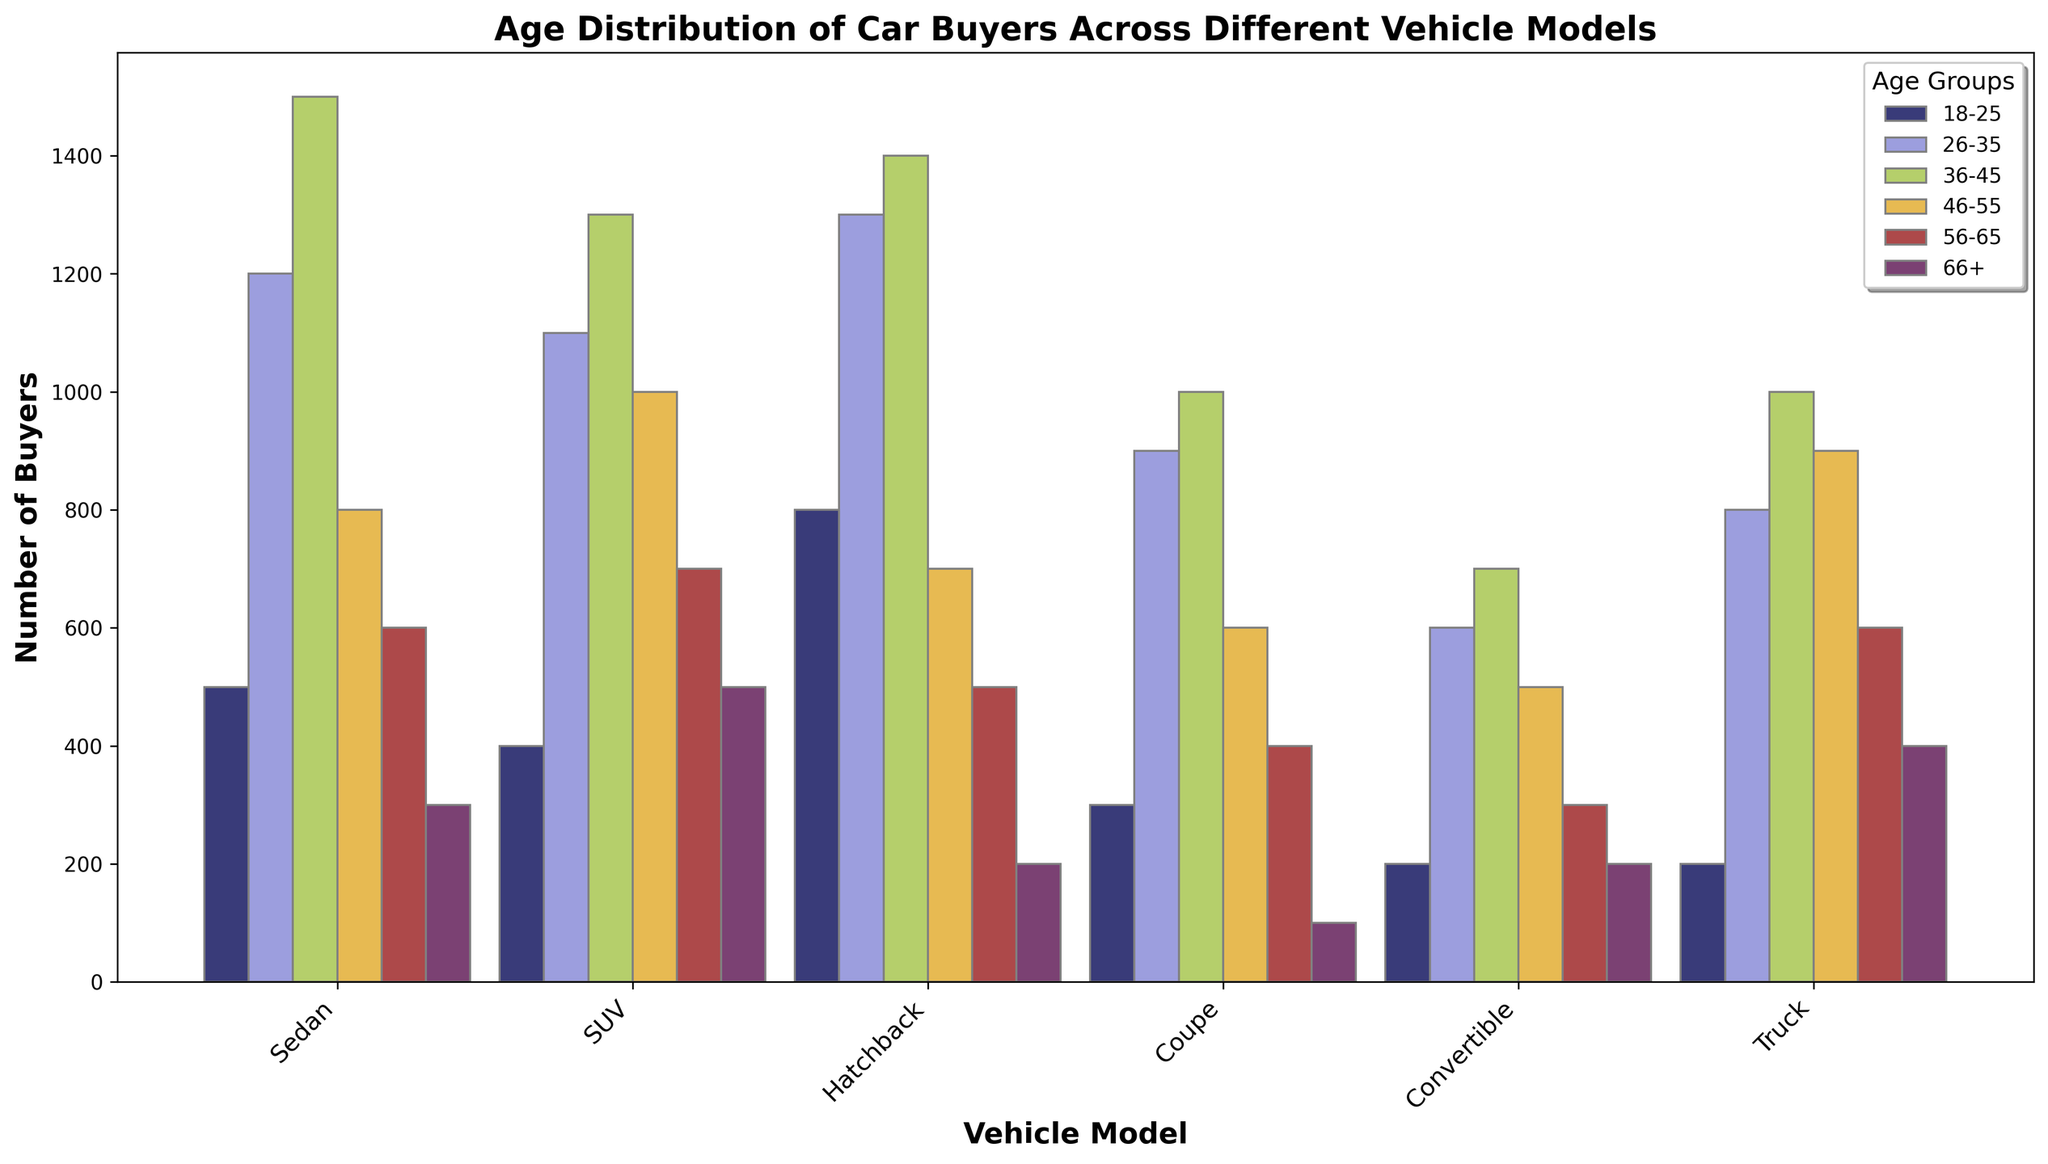What's the most popular vehicle model for buyers aged 36-45? By visual inspection, the bar for the Sedan model is the highest in the 36-45 age group.
Answer: Sedan Which age group buys the fewest Convertibles? The height of the bar representing the age group 18-25 is the shortest in the Convertible model.
Answer: 18-25 What are the combined buyers of SUVs and Trucks in the 46-55 age group? By observing the bar heights for the 46-55 age group, there are 1000 SUV buyers and 900 Truck buyers. So, combined buyers = 1000 + 900 = 1900
Answer: 1900 Which vehicle model has the highest number of buyers in the 66+ age group? By checking the tallest bars in the 66+ age group, the SUV model's bar is the highest among all models.
Answer: SUV What's the total number of buyers for the Coupe model in the age groups 26-35 and 46-55? The Coupe model has 900 buyers in the 26-35 age group and 600 in the 46-55 age group. Adding them gives 900 + 600 = 1500.
Answer: 1500 Which two vehicle models have the highest number of buyers in the 56-65 age group? Observing the bar heights for the 56-65 age group, the tallest bars are those for SUV (700) and Sedan (600).
Answer: SUV, Sedan Compare the buyers aged 18-25 for Hatchback and Convertible. Which has more buyers and by how much? The bar for the 18-25 age group shows 800 Hatchback buyers and 200 Convertible buyers. The difference is 800 - 200 = 600. Hatchback has more buyers by 600.
Answer: Hatchback by 600 What is the average number of buyers aged 26-35 across all vehicle models? Summing the buyers aged 26-35 for all models: 1200 (Sedan) + 1100 (SUV) + 1300 (Hatchback) + 900 (Coupe) + 600 (Convertible) + 800 (Truck) = 5900. There are 6 models, so the average is 5900 / 6 = 983.33
Answer: 983.33 In which age group does the Truck model have the most buyers? The tallest bar for the Truck model is in the 46-55 age group, indicating it has the most buyers here.
Answer: 46-55 